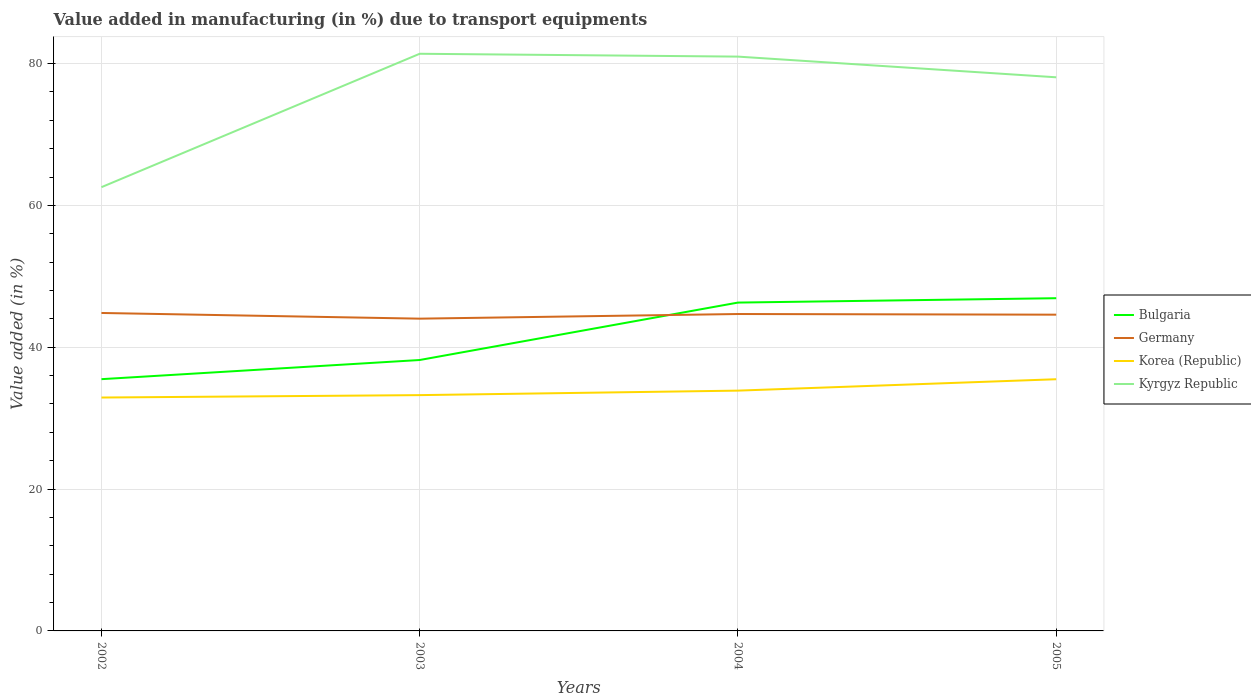Does the line corresponding to Kyrgyz Republic intersect with the line corresponding to Bulgaria?
Ensure brevity in your answer.  No. Is the number of lines equal to the number of legend labels?
Offer a terse response. Yes. Across all years, what is the maximum percentage of value added in manufacturing due to transport equipments in Germany?
Provide a succinct answer. 44.03. In which year was the percentage of value added in manufacturing due to transport equipments in Bulgaria maximum?
Your answer should be very brief. 2002. What is the total percentage of value added in manufacturing due to transport equipments in Bulgaria in the graph?
Make the answer very short. -11.42. What is the difference between the highest and the second highest percentage of value added in manufacturing due to transport equipments in Korea (Republic)?
Give a very brief answer. 2.58. What is the difference between the highest and the lowest percentage of value added in manufacturing due to transport equipments in Kyrgyz Republic?
Ensure brevity in your answer.  3. How many years are there in the graph?
Offer a very short reply. 4. What is the difference between two consecutive major ticks on the Y-axis?
Make the answer very short. 20. Are the values on the major ticks of Y-axis written in scientific E-notation?
Make the answer very short. No. Does the graph contain any zero values?
Your answer should be compact. No. Does the graph contain grids?
Your answer should be very brief. Yes. How are the legend labels stacked?
Offer a very short reply. Vertical. What is the title of the graph?
Offer a very short reply. Value added in manufacturing (in %) due to transport equipments. Does "China" appear as one of the legend labels in the graph?
Your answer should be very brief. No. What is the label or title of the X-axis?
Give a very brief answer. Years. What is the label or title of the Y-axis?
Provide a short and direct response. Value added (in %). What is the Value added (in %) in Bulgaria in 2002?
Your answer should be compact. 35.5. What is the Value added (in %) of Germany in 2002?
Offer a terse response. 44.84. What is the Value added (in %) of Korea (Republic) in 2002?
Your response must be concise. 32.91. What is the Value added (in %) of Kyrgyz Republic in 2002?
Provide a succinct answer. 62.57. What is the Value added (in %) in Bulgaria in 2003?
Your response must be concise. 38.2. What is the Value added (in %) in Germany in 2003?
Offer a very short reply. 44.03. What is the Value added (in %) in Korea (Republic) in 2003?
Give a very brief answer. 33.25. What is the Value added (in %) in Kyrgyz Republic in 2003?
Make the answer very short. 81.39. What is the Value added (in %) of Bulgaria in 2004?
Provide a short and direct response. 46.3. What is the Value added (in %) in Germany in 2004?
Your answer should be compact. 44.69. What is the Value added (in %) of Korea (Republic) in 2004?
Offer a terse response. 33.88. What is the Value added (in %) of Kyrgyz Republic in 2004?
Your response must be concise. 80.98. What is the Value added (in %) of Bulgaria in 2005?
Give a very brief answer. 46.92. What is the Value added (in %) of Germany in 2005?
Provide a succinct answer. 44.6. What is the Value added (in %) of Korea (Republic) in 2005?
Keep it short and to the point. 35.49. What is the Value added (in %) of Kyrgyz Republic in 2005?
Your response must be concise. 78.07. Across all years, what is the maximum Value added (in %) in Bulgaria?
Offer a very short reply. 46.92. Across all years, what is the maximum Value added (in %) of Germany?
Ensure brevity in your answer.  44.84. Across all years, what is the maximum Value added (in %) in Korea (Republic)?
Your response must be concise. 35.49. Across all years, what is the maximum Value added (in %) of Kyrgyz Republic?
Offer a very short reply. 81.39. Across all years, what is the minimum Value added (in %) in Bulgaria?
Your response must be concise. 35.5. Across all years, what is the minimum Value added (in %) of Germany?
Make the answer very short. 44.03. Across all years, what is the minimum Value added (in %) of Korea (Republic)?
Keep it short and to the point. 32.91. Across all years, what is the minimum Value added (in %) in Kyrgyz Republic?
Your response must be concise. 62.57. What is the total Value added (in %) in Bulgaria in the graph?
Ensure brevity in your answer.  166.92. What is the total Value added (in %) of Germany in the graph?
Offer a terse response. 178.15. What is the total Value added (in %) in Korea (Republic) in the graph?
Provide a short and direct response. 135.53. What is the total Value added (in %) in Kyrgyz Republic in the graph?
Offer a very short reply. 303.01. What is the difference between the Value added (in %) of Bulgaria in 2002 and that in 2003?
Give a very brief answer. -2.7. What is the difference between the Value added (in %) of Germany in 2002 and that in 2003?
Provide a short and direct response. 0.8. What is the difference between the Value added (in %) in Korea (Republic) in 2002 and that in 2003?
Your answer should be very brief. -0.34. What is the difference between the Value added (in %) of Kyrgyz Republic in 2002 and that in 2003?
Your answer should be very brief. -18.81. What is the difference between the Value added (in %) of Bulgaria in 2002 and that in 2004?
Provide a short and direct response. -10.8. What is the difference between the Value added (in %) in Germany in 2002 and that in 2004?
Your response must be concise. 0.15. What is the difference between the Value added (in %) in Korea (Republic) in 2002 and that in 2004?
Offer a very short reply. -0.97. What is the difference between the Value added (in %) of Kyrgyz Republic in 2002 and that in 2004?
Keep it short and to the point. -18.41. What is the difference between the Value added (in %) in Bulgaria in 2002 and that in 2005?
Your response must be concise. -11.42. What is the difference between the Value added (in %) of Germany in 2002 and that in 2005?
Your answer should be compact. 0.24. What is the difference between the Value added (in %) in Korea (Republic) in 2002 and that in 2005?
Keep it short and to the point. -2.58. What is the difference between the Value added (in %) in Kyrgyz Republic in 2002 and that in 2005?
Offer a very short reply. -15.49. What is the difference between the Value added (in %) of Bulgaria in 2003 and that in 2004?
Your answer should be compact. -8.1. What is the difference between the Value added (in %) in Germany in 2003 and that in 2004?
Offer a terse response. -0.65. What is the difference between the Value added (in %) of Korea (Republic) in 2003 and that in 2004?
Give a very brief answer. -0.63. What is the difference between the Value added (in %) in Kyrgyz Republic in 2003 and that in 2004?
Provide a succinct answer. 0.4. What is the difference between the Value added (in %) in Bulgaria in 2003 and that in 2005?
Offer a terse response. -8.71. What is the difference between the Value added (in %) of Germany in 2003 and that in 2005?
Make the answer very short. -0.56. What is the difference between the Value added (in %) in Korea (Republic) in 2003 and that in 2005?
Offer a terse response. -2.24. What is the difference between the Value added (in %) in Kyrgyz Republic in 2003 and that in 2005?
Provide a short and direct response. 3.32. What is the difference between the Value added (in %) of Bulgaria in 2004 and that in 2005?
Ensure brevity in your answer.  -0.62. What is the difference between the Value added (in %) in Germany in 2004 and that in 2005?
Your response must be concise. 0.09. What is the difference between the Value added (in %) of Korea (Republic) in 2004 and that in 2005?
Your response must be concise. -1.61. What is the difference between the Value added (in %) in Kyrgyz Republic in 2004 and that in 2005?
Your answer should be compact. 2.92. What is the difference between the Value added (in %) of Bulgaria in 2002 and the Value added (in %) of Germany in 2003?
Make the answer very short. -8.53. What is the difference between the Value added (in %) in Bulgaria in 2002 and the Value added (in %) in Korea (Republic) in 2003?
Ensure brevity in your answer.  2.25. What is the difference between the Value added (in %) of Bulgaria in 2002 and the Value added (in %) of Kyrgyz Republic in 2003?
Keep it short and to the point. -45.89. What is the difference between the Value added (in %) of Germany in 2002 and the Value added (in %) of Korea (Republic) in 2003?
Keep it short and to the point. 11.59. What is the difference between the Value added (in %) in Germany in 2002 and the Value added (in %) in Kyrgyz Republic in 2003?
Your response must be concise. -36.55. What is the difference between the Value added (in %) in Korea (Republic) in 2002 and the Value added (in %) in Kyrgyz Republic in 2003?
Ensure brevity in your answer.  -48.48. What is the difference between the Value added (in %) of Bulgaria in 2002 and the Value added (in %) of Germany in 2004?
Make the answer very short. -9.19. What is the difference between the Value added (in %) of Bulgaria in 2002 and the Value added (in %) of Korea (Republic) in 2004?
Your answer should be compact. 1.62. What is the difference between the Value added (in %) of Bulgaria in 2002 and the Value added (in %) of Kyrgyz Republic in 2004?
Your response must be concise. -45.48. What is the difference between the Value added (in %) of Germany in 2002 and the Value added (in %) of Korea (Republic) in 2004?
Provide a short and direct response. 10.95. What is the difference between the Value added (in %) in Germany in 2002 and the Value added (in %) in Kyrgyz Republic in 2004?
Give a very brief answer. -36.15. What is the difference between the Value added (in %) of Korea (Republic) in 2002 and the Value added (in %) of Kyrgyz Republic in 2004?
Offer a terse response. -48.07. What is the difference between the Value added (in %) of Bulgaria in 2002 and the Value added (in %) of Germany in 2005?
Give a very brief answer. -9.09. What is the difference between the Value added (in %) of Bulgaria in 2002 and the Value added (in %) of Korea (Republic) in 2005?
Provide a succinct answer. 0.01. What is the difference between the Value added (in %) in Bulgaria in 2002 and the Value added (in %) in Kyrgyz Republic in 2005?
Provide a short and direct response. -42.57. What is the difference between the Value added (in %) of Germany in 2002 and the Value added (in %) of Korea (Republic) in 2005?
Keep it short and to the point. 9.35. What is the difference between the Value added (in %) in Germany in 2002 and the Value added (in %) in Kyrgyz Republic in 2005?
Your answer should be very brief. -33.23. What is the difference between the Value added (in %) of Korea (Republic) in 2002 and the Value added (in %) of Kyrgyz Republic in 2005?
Provide a succinct answer. -45.16. What is the difference between the Value added (in %) in Bulgaria in 2003 and the Value added (in %) in Germany in 2004?
Keep it short and to the point. -6.48. What is the difference between the Value added (in %) of Bulgaria in 2003 and the Value added (in %) of Korea (Republic) in 2004?
Your response must be concise. 4.32. What is the difference between the Value added (in %) in Bulgaria in 2003 and the Value added (in %) in Kyrgyz Republic in 2004?
Make the answer very short. -42.78. What is the difference between the Value added (in %) of Germany in 2003 and the Value added (in %) of Korea (Republic) in 2004?
Ensure brevity in your answer.  10.15. What is the difference between the Value added (in %) of Germany in 2003 and the Value added (in %) of Kyrgyz Republic in 2004?
Offer a very short reply. -36.95. What is the difference between the Value added (in %) of Korea (Republic) in 2003 and the Value added (in %) of Kyrgyz Republic in 2004?
Your answer should be very brief. -47.73. What is the difference between the Value added (in %) of Bulgaria in 2003 and the Value added (in %) of Germany in 2005?
Make the answer very short. -6.39. What is the difference between the Value added (in %) in Bulgaria in 2003 and the Value added (in %) in Korea (Republic) in 2005?
Give a very brief answer. 2.71. What is the difference between the Value added (in %) in Bulgaria in 2003 and the Value added (in %) in Kyrgyz Republic in 2005?
Ensure brevity in your answer.  -39.87. What is the difference between the Value added (in %) in Germany in 2003 and the Value added (in %) in Korea (Republic) in 2005?
Your answer should be very brief. 8.54. What is the difference between the Value added (in %) in Germany in 2003 and the Value added (in %) in Kyrgyz Republic in 2005?
Keep it short and to the point. -34.04. What is the difference between the Value added (in %) of Korea (Republic) in 2003 and the Value added (in %) of Kyrgyz Republic in 2005?
Your answer should be compact. -44.82. What is the difference between the Value added (in %) in Bulgaria in 2004 and the Value added (in %) in Germany in 2005?
Your answer should be compact. 1.7. What is the difference between the Value added (in %) of Bulgaria in 2004 and the Value added (in %) of Korea (Republic) in 2005?
Your response must be concise. 10.81. What is the difference between the Value added (in %) in Bulgaria in 2004 and the Value added (in %) in Kyrgyz Republic in 2005?
Your answer should be very brief. -31.77. What is the difference between the Value added (in %) in Germany in 2004 and the Value added (in %) in Korea (Republic) in 2005?
Provide a succinct answer. 9.2. What is the difference between the Value added (in %) in Germany in 2004 and the Value added (in %) in Kyrgyz Republic in 2005?
Give a very brief answer. -33.38. What is the difference between the Value added (in %) of Korea (Republic) in 2004 and the Value added (in %) of Kyrgyz Republic in 2005?
Offer a terse response. -44.18. What is the average Value added (in %) of Bulgaria per year?
Provide a short and direct response. 41.73. What is the average Value added (in %) in Germany per year?
Keep it short and to the point. 44.54. What is the average Value added (in %) in Korea (Republic) per year?
Your answer should be compact. 33.88. What is the average Value added (in %) of Kyrgyz Republic per year?
Make the answer very short. 75.75. In the year 2002, what is the difference between the Value added (in %) of Bulgaria and Value added (in %) of Germany?
Offer a very short reply. -9.34. In the year 2002, what is the difference between the Value added (in %) of Bulgaria and Value added (in %) of Korea (Republic)?
Offer a very short reply. 2.59. In the year 2002, what is the difference between the Value added (in %) of Bulgaria and Value added (in %) of Kyrgyz Republic?
Your response must be concise. -27.07. In the year 2002, what is the difference between the Value added (in %) of Germany and Value added (in %) of Korea (Republic)?
Provide a succinct answer. 11.93. In the year 2002, what is the difference between the Value added (in %) in Germany and Value added (in %) in Kyrgyz Republic?
Keep it short and to the point. -17.74. In the year 2002, what is the difference between the Value added (in %) of Korea (Republic) and Value added (in %) of Kyrgyz Republic?
Your response must be concise. -29.66. In the year 2003, what is the difference between the Value added (in %) in Bulgaria and Value added (in %) in Germany?
Keep it short and to the point. -5.83. In the year 2003, what is the difference between the Value added (in %) of Bulgaria and Value added (in %) of Korea (Republic)?
Your answer should be compact. 4.95. In the year 2003, what is the difference between the Value added (in %) of Bulgaria and Value added (in %) of Kyrgyz Republic?
Ensure brevity in your answer.  -43.18. In the year 2003, what is the difference between the Value added (in %) in Germany and Value added (in %) in Korea (Republic)?
Give a very brief answer. 10.78. In the year 2003, what is the difference between the Value added (in %) of Germany and Value added (in %) of Kyrgyz Republic?
Your answer should be compact. -37.35. In the year 2003, what is the difference between the Value added (in %) of Korea (Republic) and Value added (in %) of Kyrgyz Republic?
Provide a succinct answer. -48.14. In the year 2004, what is the difference between the Value added (in %) of Bulgaria and Value added (in %) of Germany?
Your answer should be compact. 1.61. In the year 2004, what is the difference between the Value added (in %) in Bulgaria and Value added (in %) in Korea (Republic)?
Your answer should be very brief. 12.41. In the year 2004, what is the difference between the Value added (in %) in Bulgaria and Value added (in %) in Kyrgyz Republic?
Your answer should be very brief. -34.68. In the year 2004, what is the difference between the Value added (in %) of Germany and Value added (in %) of Korea (Republic)?
Provide a succinct answer. 10.8. In the year 2004, what is the difference between the Value added (in %) of Germany and Value added (in %) of Kyrgyz Republic?
Your answer should be very brief. -36.3. In the year 2004, what is the difference between the Value added (in %) of Korea (Republic) and Value added (in %) of Kyrgyz Republic?
Provide a succinct answer. -47.1. In the year 2005, what is the difference between the Value added (in %) in Bulgaria and Value added (in %) in Germany?
Your answer should be very brief. 2.32. In the year 2005, what is the difference between the Value added (in %) in Bulgaria and Value added (in %) in Korea (Republic)?
Your answer should be compact. 11.43. In the year 2005, what is the difference between the Value added (in %) of Bulgaria and Value added (in %) of Kyrgyz Republic?
Your response must be concise. -31.15. In the year 2005, what is the difference between the Value added (in %) of Germany and Value added (in %) of Korea (Republic)?
Offer a terse response. 9.11. In the year 2005, what is the difference between the Value added (in %) of Germany and Value added (in %) of Kyrgyz Republic?
Provide a succinct answer. -33.47. In the year 2005, what is the difference between the Value added (in %) of Korea (Republic) and Value added (in %) of Kyrgyz Republic?
Provide a succinct answer. -42.58. What is the ratio of the Value added (in %) of Bulgaria in 2002 to that in 2003?
Make the answer very short. 0.93. What is the ratio of the Value added (in %) of Germany in 2002 to that in 2003?
Your answer should be compact. 1.02. What is the ratio of the Value added (in %) of Korea (Republic) in 2002 to that in 2003?
Keep it short and to the point. 0.99. What is the ratio of the Value added (in %) in Kyrgyz Republic in 2002 to that in 2003?
Ensure brevity in your answer.  0.77. What is the ratio of the Value added (in %) of Bulgaria in 2002 to that in 2004?
Provide a short and direct response. 0.77. What is the ratio of the Value added (in %) of Germany in 2002 to that in 2004?
Your answer should be very brief. 1. What is the ratio of the Value added (in %) in Korea (Republic) in 2002 to that in 2004?
Your answer should be compact. 0.97. What is the ratio of the Value added (in %) in Kyrgyz Republic in 2002 to that in 2004?
Give a very brief answer. 0.77. What is the ratio of the Value added (in %) in Bulgaria in 2002 to that in 2005?
Provide a succinct answer. 0.76. What is the ratio of the Value added (in %) in Germany in 2002 to that in 2005?
Your answer should be compact. 1.01. What is the ratio of the Value added (in %) in Korea (Republic) in 2002 to that in 2005?
Offer a very short reply. 0.93. What is the ratio of the Value added (in %) of Kyrgyz Republic in 2002 to that in 2005?
Give a very brief answer. 0.8. What is the ratio of the Value added (in %) in Bulgaria in 2003 to that in 2004?
Make the answer very short. 0.83. What is the ratio of the Value added (in %) in Korea (Republic) in 2003 to that in 2004?
Make the answer very short. 0.98. What is the ratio of the Value added (in %) in Kyrgyz Republic in 2003 to that in 2004?
Offer a very short reply. 1. What is the ratio of the Value added (in %) in Bulgaria in 2003 to that in 2005?
Offer a terse response. 0.81. What is the ratio of the Value added (in %) of Germany in 2003 to that in 2005?
Offer a terse response. 0.99. What is the ratio of the Value added (in %) of Korea (Republic) in 2003 to that in 2005?
Offer a very short reply. 0.94. What is the ratio of the Value added (in %) of Kyrgyz Republic in 2003 to that in 2005?
Offer a very short reply. 1.04. What is the ratio of the Value added (in %) of Bulgaria in 2004 to that in 2005?
Your answer should be very brief. 0.99. What is the ratio of the Value added (in %) of Germany in 2004 to that in 2005?
Provide a succinct answer. 1. What is the ratio of the Value added (in %) of Korea (Republic) in 2004 to that in 2005?
Keep it short and to the point. 0.95. What is the ratio of the Value added (in %) of Kyrgyz Republic in 2004 to that in 2005?
Make the answer very short. 1.04. What is the difference between the highest and the second highest Value added (in %) in Bulgaria?
Offer a very short reply. 0.62. What is the difference between the highest and the second highest Value added (in %) in Germany?
Your answer should be very brief. 0.15. What is the difference between the highest and the second highest Value added (in %) in Korea (Republic)?
Your response must be concise. 1.61. What is the difference between the highest and the second highest Value added (in %) in Kyrgyz Republic?
Ensure brevity in your answer.  0.4. What is the difference between the highest and the lowest Value added (in %) of Bulgaria?
Your response must be concise. 11.42. What is the difference between the highest and the lowest Value added (in %) in Germany?
Offer a very short reply. 0.8. What is the difference between the highest and the lowest Value added (in %) of Korea (Republic)?
Offer a very short reply. 2.58. What is the difference between the highest and the lowest Value added (in %) in Kyrgyz Republic?
Keep it short and to the point. 18.81. 